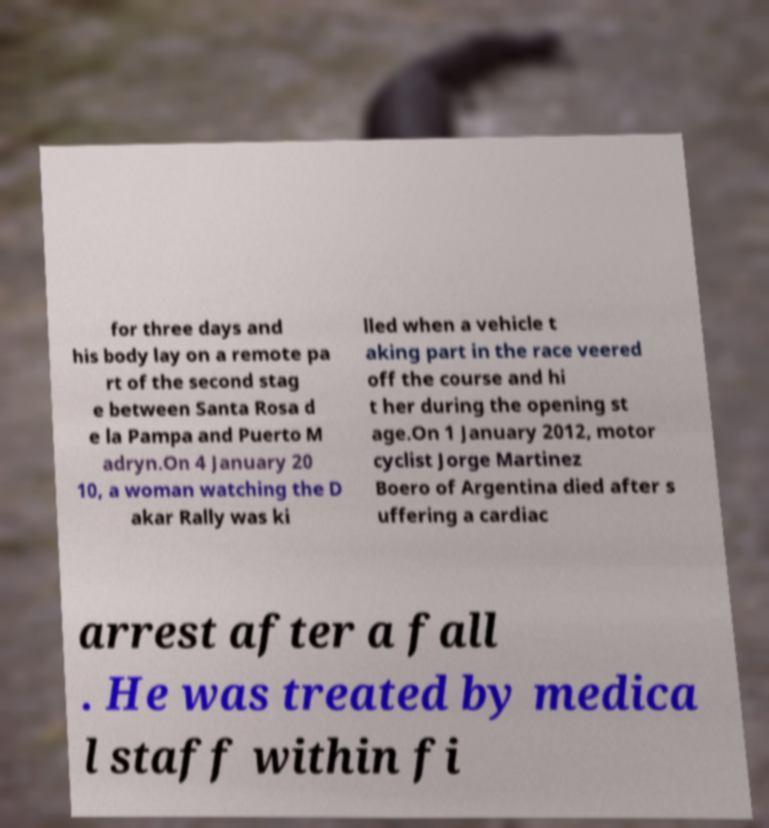What messages or text are displayed in this image? I need them in a readable, typed format. for three days and his body lay on a remote pa rt of the second stag e between Santa Rosa d e la Pampa and Puerto M adryn.On 4 January 20 10, a woman watching the D akar Rally was ki lled when a vehicle t aking part in the race veered off the course and hi t her during the opening st age.On 1 January 2012, motor cyclist Jorge Martinez Boero of Argentina died after s uffering a cardiac arrest after a fall . He was treated by medica l staff within fi 